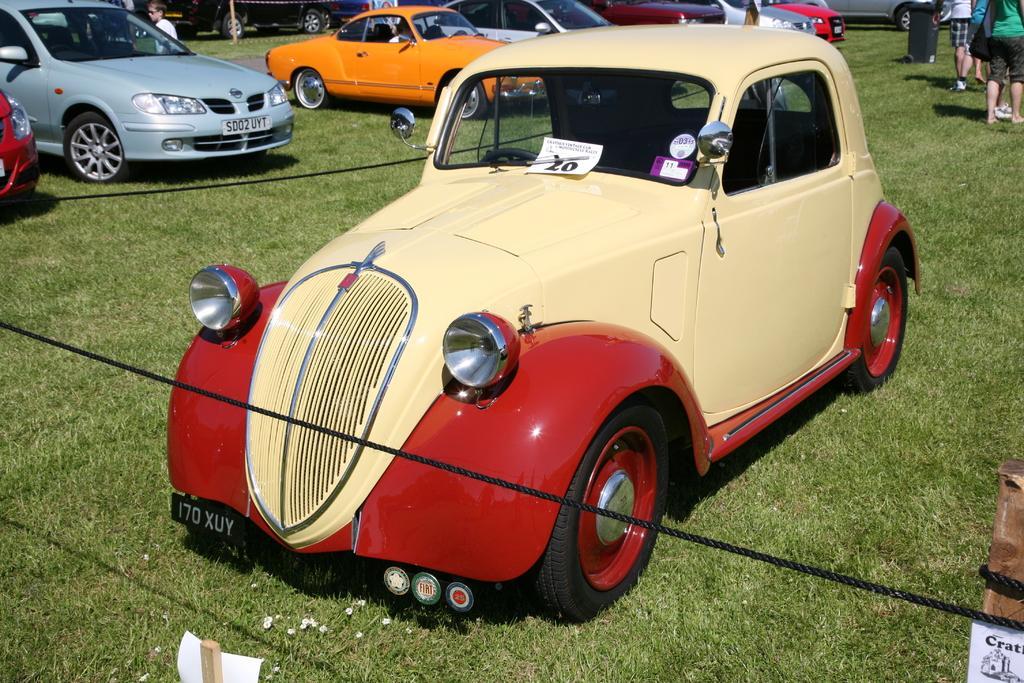Describe this image in one or two sentences. In this image we can see vehicles on the grass. Here we can see ropes, posters, sticks, bin, and a person. At the top right corner of the image we can see people. 